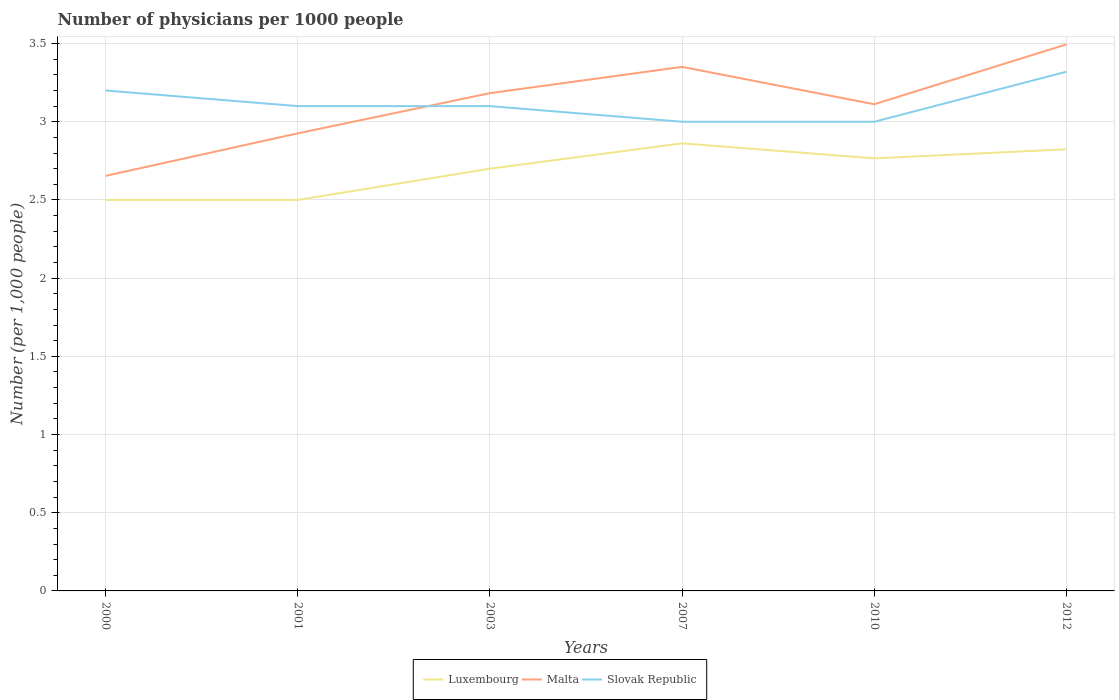How many different coloured lines are there?
Keep it short and to the point. 3. Is the number of lines equal to the number of legend labels?
Make the answer very short. Yes. In which year was the number of physicians in Luxembourg maximum?
Make the answer very short. 2000. What is the total number of physicians in Slovak Republic in the graph?
Keep it short and to the point. 0.1. What is the difference between the highest and the second highest number of physicians in Luxembourg?
Give a very brief answer. 0.36. What is the difference between the highest and the lowest number of physicians in Slovak Republic?
Your response must be concise. 2. Is the number of physicians in Slovak Republic strictly greater than the number of physicians in Luxembourg over the years?
Your answer should be compact. No. How many years are there in the graph?
Your response must be concise. 6. Does the graph contain grids?
Provide a succinct answer. Yes. Where does the legend appear in the graph?
Keep it short and to the point. Bottom center. How are the legend labels stacked?
Your answer should be compact. Horizontal. What is the title of the graph?
Keep it short and to the point. Number of physicians per 1000 people. What is the label or title of the X-axis?
Give a very brief answer. Years. What is the label or title of the Y-axis?
Make the answer very short. Number (per 1,0 people). What is the Number (per 1,000 people) of Malta in 2000?
Offer a terse response. 2.65. What is the Number (per 1,000 people) in Malta in 2001?
Give a very brief answer. 2.93. What is the Number (per 1,000 people) of Slovak Republic in 2001?
Your response must be concise. 3.1. What is the Number (per 1,000 people) of Malta in 2003?
Make the answer very short. 3.18. What is the Number (per 1,000 people) of Slovak Republic in 2003?
Provide a short and direct response. 3.1. What is the Number (per 1,000 people) in Luxembourg in 2007?
Provide a short and direct response. 2.86. What is the Number (per 1,000 people) in Malta in 2007?
Give a very brief answer. 3.35. What is the Number (per 1,000 people) in Slovak Republic in 2007?
Your response must be concise. 3. What is the Number (per 1,000 people) in Luxembourg in 2010?
Your response must be concise. 2.77. What is the Number (per 1,000 people) in Malta in 2010?
Your answer should be very brief. 3.11. What is the Number (per 1,000 people) in Slovak Republic in 2010?
Your answer should be compact. 3. What is the Number (per 1,000 people) of Luxembourg in 2012?
Ensure brevity in your answer.  2.82. What is the Number (per 1,000 people) of Malta in 2012?
Provide a succinct answer. 3.5. What is the Number (per 1,000 people) of Slovak Republic in 2012?
Provide a succinct answer. 3.32. Across all years, what is the maximum Number (per 1,000 people) in Luxembourg?
Provide a succinct answer. 2.86. Across all years, what is the maximum Number (per 1,000 people) of Malta?
Keep it short and to the point. 3.5. Across all years, what is the maximum Number (per 1,000 people) of Slovak Republic?
Keep it short and to the point. 3.32. Across all years, what is the minimum Number (per 1,000 people) in Luxembourg?
Your answer should be very brief. 2.5. Across all years, what is the minimum Number (per 1,000 people) in Malta?
Make the answer very short. 2.65. Across all years, what is the minimum Number (per 1,000 people) in Slovak Republic?
Provide a short and direct response. 3. What is the total Number (per 1,000 people) in Luxembourg in the graph?
Provide a short and direct response. 16.15. What is the total Number (per 1,000 people) of Malta in the graph?
Your answer should be very brief. 18.72. What is the total Number (per 1,000 people) of Slovak Republic in the graph?
Provide a succinct answer. 18.72. What is the difference between the Number (per 1,000 people) in Malta in 2000 and that in 2001?
Offer a terse response. -0.27. What is the difference between the Number (per 1,000 people) of Slovak Republic in 2000 and that in 2001?
Offer a terse response. 0.1. What is the difference between the Number (per 1,000 people) of Malta in 2000 and that in 2003?
Keep it short and to the point. -0.53. What is the difference between the Number (per 1,000 people) in Slovak Republic in 2000 and that in 2003?
Your answer should be very brief. 0.1. What is the difference between the Number (per 1,000 people) of Luxembourg in 2000 and that in 2007?
Your response must be concise. -0.36. What is the difference between the Number (per 1,000 people) in Malta in 2000 and that in 2007?
Give a very brief answer. -0.7. What is the difference between the Number (per 1,000 people) of Slovak Republic in 2000 and that in 2007?
Your answer should be compact. 0.2. What is the difference between the Number (per 1,000 people) of Luxembourg in 2000 and that in 2010?
Your response must be concise. -0.27. What is the difference between the Number (per 1,000 people) of Malta in 2000 and that in 2010?
Your response must be concise. -0.46. What is the difference between the Number (per 1,000 people) of Luxembourg in 2000 and that in 2012?
Provide a succinct answer. -0.32. What is the difference between the Number (per 1,000 people) of Malta in 2000 and that in 2012?
Ensure brevity in your answer.  -0.84. What is the difference between the Number (per 1,000 people) of Slovak Republic in 2000 and that in 2012?
Your response must be concise. -0.12. What is the difference between the Number (per 1,000 people) in Malta in 2001 and that in 2003?
Make the answer very short. -0.26. What is the difference between the Number (per 1,000 people) of Slovak Republic in 2001 and that in 2003?
Give a very brief answer. 0. What is the difference between the Number (per 1,000 people) in Luxembourg in 2001 and that in 2007?
Make the answer very short. -0.36. What is the difference between the Number (per 1,000 people) of Malta in 2001 and that in 2007?
Provide a short and direct response. -0.42. What is the difference between the Number (per 1,000 people) in Luxembourg in 2001 and that in 2010?
Your answer should be very brief. -0.27. What is the difference between the Number (per 1,000 people) of Malta in 2001 and that in 2010?
Keep it short and to the point. -0.19. What is the difference between the Number (per 1,000 people) in Luxembourg in 2001 and that in 2012?
Provide a succinct answer. -0.32. What is the difference between the Number (per 1,000 people) in Malta in 2001 and that in 2012?
Provide a succinct answer. -0.57. What is the difference between the Number (per 1,000 people) of Slovak Republic in 2001 and that in 2012?
Give a very brief answer. -0.22. What is the difference between the Number (per 1,000 people) in Luxembourg in 2003 and that in 2007?
Provide a short and direct response. -0.16. What is the difference between the Number (per 1,000 people) of Malta in 2003 and that in 2007?
Your response must be concise. -0.17. What is the difference between the Number (per 1,000 people) of Luxembourg in 2003 and that in 2010?
Ensure brevity in your answer.  -0.07. What is the difference between the Number (per 1,000 people) of Malta in 2003 and that in 2010?
Give a very brief answer. 0.07. What is the difference between the Number (per 1,000 people) in Luxembourg in 2003 and that in 2012?
Offer a very short reply. -0.12. What is the difference between the Number (per 1,000 people) in Malta in 2003 and that in 2012?
Offer a terse response. -0.31. What is the difference between the Number (per 1,000 people) of Slovak Republic in 2003 and that in 2012?
Your answer should be very brief. -0.22. What is the difference between the Number (per 1,000 people) in Luxembourg in 2007 and that in 2010?
Keep it short and to the point. 0.1. What is the difference between the Number (per 1,000 people) in Malta in 2007 and that in 2010?
Ensure brevity in your answer.  0.24. What is the difference between the Number (per 1,000 people) in Luxembourg in 2007 and that in 2012?
Make the answer very short. 0.04. What is the difference between the Number (per 1,000 people) in Malta in 2007 and that in 2012?
Offer a terse response. -0.14. What is the difference between the Number (per 1,000 people) of Slovak Republic in 2007 and that in 2012?
Your response must be concise. -0.32. What is the difference between the Number (per 1,000 people) of Luxembourg in 2010 and that in 2012?
Ensure brevity in your answer.  -0.06. What is the difference between the Number (per 1,000 people) in Malta in 2010 and that in 2012?
Your response must be concise. -0.38. What is the difference between the Number (per 1,000 people) of Slovak Republic in 2010 and that in 2012?
Provide a succinct answer. -0.32. What is the difference between the Number (per 1,000 people) of Luxembourg in 2000 and the Number (per 1,000 people) of Malta in 2001?
Your response must be concise. -0.43. What is the difference between the Number (per 1,000 people) of Malta in 2000 and the Number (per 1,000 people) of Slovak Republic in 2001?
Offer a very short reply. -0.45. What is the difference between the Number (per 1,000 people) of Luxembourg in 2000 and the Number (per 1,000 people) of Malta in 2003?
Provide a short and direct response. -0.68. What is the difference between the Number (per 1,000 people) in Luxembourg in 2000 and the Number (per 1,000 people) in Slovak Republic in 2003?
Offer a very short reply. -0.6. What is the difference between the Number (per 1,000 people) in Malta in 2000 and the Number (per 1,000 people) in Slovak Republic in 2003?
Ensure brevity in your answer.  -0.45. What is the difference between the Number (per 1,000 people) of Luxembourg in 2000 and the Number (per 1,000 people) of Malta in 2007?
Provide a succinct answer. -0.85. What is the difference between the Number (per 1,000 people) of Malta in 2000 and the Number (per 1,000 people) of Slovak Republic in 2007?
Offer a very short reply. -0.35. What is the difference between the Number (per 1,000 people) in Luxembourg in 2000 and the Number (per 1,000 people) in Malta in 2010?
Your answer should be compact. -0.61. What is the difference between the Number (per 1,000 people) of Malta in 2000 and the Number (per 1,000 people) of Slovak Republic in 2010?
Your answer should be very brief. -0.35. What is the difference between the Number (per 1,000 people) of Luxembourg in 2000 and the Number (per 1,000 people) of Malta in 2012?
Keep it short and to the point. -0.99. What is the difference between the Number (per 1,000 people) in Luxembourg in 2000 and the Number (per 1,000 people) in Slovak Republic in 2012?
Keep it short and to the point. -0.82. What is the difference between the Number (per 1,000 people) in Malta in 2000 and the Number (per 1,000 people) in Slovak Republic in 2012?
Provide a short and direct response. -0.67. What is the difference between the Number (per 1,000 people) in Luxembourg in 2001 and the Number (per 1,000 people) in Malta in 2003?
Offer a terse response. -0.68. What is the difference between the Number (per 1,000 people) in Malta in 2001 and the Number (per 1,000 people) in Slovak Republic in 2003?
Offer a very short reply. -0.17. What is the difference between the Number (per 1,000 people) of Luxembourg in 2001 and the Number (per 1,000 people) of Malta in 2007?
Your answer should be very brief. -0.85. What is the difference between the Number (per 1,000 people) in Luxembourg in 2001 and the Number (per 1,000 people) in Slovak Republic in 2007?
Make the answer very short. -0.5. What is the difference between the Number (per 1,000 people) of Malta in 2001 and the Number (per 1,000 people) of Slovak Republic in 2007?
Your response must be concise. -0.07. What is the difference between the Number (per 1,000 people) in Luxembourg in 2001 and the Number (per 1,000 people) in Malta in 2010?
Ensure brevity in your answer.  -0.61. What is the difference between the Number (per 1,000 people) of Luxembourg in 2001 and the Number (per 1,000 people) of Slovak Republic in 2010?
Ensure brevity in your answer.  -0.5. What is the difference between the Number (per 1,000 people) in Malta in 2001 and the Number (per 1,000 people) in Slovak Republic in 2010?
Your answer should be compact. -0.07. What is the difference between the Number (per 1,000 people) of Luxembourg in 2001 and the Number (per 1,000 people) of Malta in 2012?
Provide a succinct answer. -0.99. What is the difference between the Number (per 1,000 people) in Luxembourg in 2001 and the Number (per 1,000 people) in Slovak Republic in 2012?
Offer a very short reply. -0.82. What is the difference between the Number (per 1,000 people) in Malta in 2001 and the Number (per 1,000 people) in Slovak Republic in 2012?
Provide a short and direct response. -0.39. What is the difference between the Number (per 1,000 people) of Luxembourg in 2003 and the Number (per 1,000 people) of Malta in 2007?
Provide a short and direct response. -0.65. What is the difference between the Number (per 1,000 people) in Luxembourg in 2003 and the Number (per 1,000 people) in Slovak Republic in 2007?
Make the answer very short. -0.3. What is the difference between the Number (per 1,000 people) of Malta in 2003 and the Number (per 1,000 people) of Slovak Republic in 2007?
Offer a very short reply. 0.18. What is the difference between the Number (per 1,000 people) in Luxembourg in 2003 and the Number (per 1,000 people) in Malta in 2010?
Your answer should be compact. -0.41. What is the difference between the Number (per 1,000 people) of Luxembourg in 2003 and the Number (per 1,000 people) of Slovak Republic in 2010?
Give a very brief answer. -0.3. What is the difference between the Number (per 1,000 people) in Malta in 2003 and the Number (per 1,000 people) in Slovak Republic in 2010?
Offer a very short reply. 0.18. What is the difference between the Number (per 1,000 people) in Luxembourg in 2003 and the Number (per 1,000 people) in Malta in 2012?
Your answer should be compact. -0.8. What is the difference between the Number (per 1,000 people) in Luxembourg in 2003 and the Number (per 1,000 people) in Slovak Republic in 2012?
Offer a terse response. -0.62. What is the difference between the Number (per 1,000 people) of Malta in 2003 and the Number (per 1,000 people) of Slovak Republic in 2012?
Offer a terse response. -0.14. What is the difference between the Number (per 1,000 people) of Luxembourg in 2007 and the Number (per 1,000 people) of Slovak Republic in 2010?
Offer a terse response. -0.14. What is the difference between the Number (per 1,000 people) of Malta in 2007 and the Number (per 1,000 people) of Slovak Republic in 2010?
Provide a short and direct response. 0.35. What is the difference between the Number (per 1,000 people) in Luxembourg in 2007 and the Number (per 1,000 people) in Malta in 2012?
Give a very brief answer. -0.63. What is the difference between the Number (per 1,000 people) in Luxembourg in 2007 and the Number (per 1,000 people) in Slovak Republic in 2012?
Your answer should be very brief. -0.46. What is the difference between the Number (per 1,000 people) of Malta in 2007 and the Number (per 1,000 people) of Slovak Republic in 2012?
Provide a short and direct response. 0.03. What is the difference between the Number (per 1,000 people) in Luxembourg in 2010 and the Number (per 1,000 people) in Malta in 2012?
Your answer should be very brief. -0.73. What is the difference between the Number (per 1,000 people) of Luxembourg in 2010 and the Number (per 1,000 people) of Slovak Republic in 2012?
Your answer should be compact. -0.55. What is the difference between the Number (per 1,000 people) in Malta in 2010 and the Number (per 1,000 people) in Slovak Republic in 2012?
Your answer should be very brief. -0.21. What is the average Number (per 1,000 people) in Luxembourg per year?
Give a very brief answer. 2.69. What is the average Number (per 1,000 people) in Malta per year?
Give a very brief answer. 3.12. What is the average Number (per 1,000 people) of Slovak Republic per year?
Your response must be concise. 3.12. In the year 2000, what is the difference between the Number (per 1,000 people) in Luxembourg and Number (per 1,000 people) in Malta?
Offer a very short reply. -0.15. In the year 2000, what is the difference between the Number (per 1,000 people) in Luxembourg and Number (per 1,000 people) in Slovak Republic?
Your response must be concise. -0.7. In the year 2000, what is the difference between the Number (per 1,000 people) in Malta and Number (per 1,000 people) in Slovak Republic?
Ensure brevity in your answer.  -0.55. In the year 2001, what is the difference between the Number (per 1,000 people) in Luxembourg and Number (per 1,000 people) in Malta?
Your answer should be very brief. -0.43. In the year 2001, what is the difference between the Number (per 1,000 people) in Luxembourg and Number (per 1,000 people) in Slovak Republic?
Provide a short and direct response. -0.6. In the year 2001, what is the difference between the Number (per 1,000 people) in Malta and Number (per 1,000 people) in Slovak Republic?
Give a very brief answer. -0.17. In the year 2003, what is the difference between the Number (per 1,000 people) of Luxembourg and Number (per 1,000 people) of Malta?
Give a very brief answer. -0.48. In the year 2003, what is the difference between the Number (per 1,000 people) in Malta and Number (per 1,000 people) in Slovak Republic?
Keep it short and to the point. 0.08. In the year 2007, what is the difference between the Number (per 1,000 people) of Luxembourg and Number (per 1,000 people) of Malta?
Your answer should be very brief. -0.49. In the year 2007, what is the difference between the Number (per 1,000 people) of Luxembourg and Number (per 1,000 people) of Slovak Republic?
Your answer should be compact. -0.14. In the year 2007, what is the difference between the Number (per 1,000 people) in Malta and Number (per 1,000 people) in Slovak Republic?
Keep it short and to the point. 0.35. In the year 2010, what is the difference between the Number (per 1,000 people) in Luxembourg and Number (per 1,000 people) in Malta?
Provide a short and direct response. -0.35. In the year 2010, what is the difference between the Number (per 1,000 people) in Luxembourg and Number (per 1,000 people) in Slovak Republic?
Your answer should be compact. -0.23. In the year 2010, what is the difference between the Number (per 1,000 people) in Malta and Number (per 1,000 people) in Slovak Republic?
Provide a succinct answer. 0.11. In the year 2012, what is the difference between the Number (per 1,000 people) of Luxembourg and Number (per 1,000 people) of Malta?
Keep it short and to the point. -0.67. In the year 2012, what is the difference between the Number (per 1,000 people) of Luxembourg and Number (per 1,000 people) of Slovak Republic?
Offer a very short reply. -0.5. In the year 2012, what is the difference between the Number (per 1,000 people) in Malta and Number (per 1,000 people) in Slovak Republic?
Offer a terse response. 0.17. What is the ratio of the Number (per 1,000 people) in Luxembourg in 2000 to that in 2001?
Provide a succinct answer. 1. What is the ratio of the Number (per 1,000 people) in Malta in 2000 to that in 2001?
Offer a very short reply. 0.91. What is the ratio of the Number (per 1,000 people) in Slovak Republic in 2000 to that in 2001?
Your answer should be very brief. 1.03. What is the ratio of the Number (per 1,000 people) in Luxembourg in 2000 to that in 2003?
Ensure brevity in your answer.  0.93. What is the ratio of the Number (per 1,000 people) of Malta in 2000 to that in 2003?
Keep it short and to the point. 0.83. What is the ratio of the Number (per 1,000 people) of Slovak Republic in 2000 to that in 2003?
Keep it short and to the point. 1.03. What is the ratio of the Number (per 1,000 people) of Luxembourg in 2000 to that in 2007?
Make the answer very short. 0.87. What is the ratio of the Number (per 1,000 people) in Malta in 2000 to that in 2007?
Make the answer very short. 0.79. What is the ratio of the Number (per 1,000 people) of Slovak Republic in 2000 to that in 2007?
Keep it short and to the point. 1.07. What is the ratio of the Number (per 1,000 people) in Luxembourg in 2000 to that in 2010?
Your response must be concise. 0.9. What is the ratio of the Number (per 1,000 people) of Malta in 2000 to that in 2010?
Offer a very short reply. 0.85. What is the ratio of the Number (per 1,000 people) of Slovak Republic in 2000 to that in 2010?
Give a very brief answer. 1.07. What is the ratio of the Number (per 1,000 people) of Luxembourg in 2000 to that in 2012?
Offer a terse response. 0.89. What is the ratio of the Number (per 1,000 people) of Malta in 2000 to that in 2012?
Ensure brevity in your answer.  0.76. What is the ratio of the Number (per 1,000 people) of Slovak Republic in 2000 to that in 2012?
Your answer should be compact. 0.96. What is the ratio of the Number (per 1,000 people) of Luxembourg in 2001 to that in 2003?
Offer a terse response. 0.93. What is the ratio of the Number (per 1,000 people) in Malta in 2001 to that in 2003?
Provide a short and direct response. 0.92. What is the ratio of the Number (per 1,000 people) in Slovak Republic in 2001 to that in 2003?
Ensure brevity in your answer.  1. What is the ratio of the Number (per 1,000 people) of Luxembourg in 2001 to that in 2007?
Provide a short and direct response. 0.87. What is the ratio of the Number (per 1,000 people) of Malta in 2001 to that in 2007?
Give a very brief answer. 0.87. What is the ratio of the Number (per 1,000 people) in Luxembourg in 2001 to that in 2010?
Your response must be concise. 0.9. What is the ratio of the Number (per 1,000 people) in Malta in 2001 to that in 2010?
Offer a very short reply. 0.94. What is the ratio of the Number (per 1,000 people) in Luxembourg in 2001 to that in 2012?
Your answer should be compact. 0.89. What is the ratio of the Number (per 1,000 people) in Malta in 2001 to that in 2012?
Your answer should be very brief. 0.84. What is the ratio of the Number (per 1,000 people) in Slovak Republic in 2001 to that in 2012?
Make the answer very short. 0.93. What is the ratio of the Number (per 1,000 people) in Luxembourg in 2003 to that in 2007?
Your answer should be very brief. 0.94. What is the ratio of the Number (per 1,000 people) in Malta in 2003 to that in 2007?
Provide a succinct answer. 0.95. What is the ratio of the Number (per 1,000 people) of Slovak Republic in 2003 to that in 2007?
Ensure brevity in your answer.  1.03. What is the ratio of the Number (per 1,000 people) of Luxembourg in 2003 to that in 2010?
Make the answer very short. 0.98. What is the ratio of the Number (per 1,000 people) of Malta in 2003 to that in 2010?
Offer a very short reply. 1.02. What is the ratio of the Number (per 1,000 people) of Luxembourg in 2003 to that in 2012?
Your answer should be very brief. 0.96. What is the ratio of the Number (per 1,000 people) of Malta in 2003 to that in 2012?
Your answer should be very brief. 0.91. What is the ratio of the Number (per 1,000 people) in Slovak Republic in 2003 to that in 2012?
Your answer should be very brief. 0.93. What is the ratio of the Number (per 1,000 people) of Luxembourg in 2007 to that in 2010?
Provide a succinct answer. 1.03. What is the ratio of the Number (per 1,000 people) of Malta in 2007 to that in 2010?
Provide a succinct answer. 1.08. What is the ratio of the Number (per 1,000 people) of Luxembourg in 2007 to that in 2012?
Provide a short and direct response. 1.01. What is the ratio of the Number (per 1,000 people) of Malta in 2007 to that in 2012?
Make the answer very short. 0.96. What is the ratio of the Number (per 1,000 people) in Slovak Republic in 2007 to that in 2012?
Offer a terse response. 0.9. What is the ratio of the Number (per 1,000 people) in Luxembourg in 2010 to that in 2012?
Offer a terse response. 0.98. What is the ratio of the Number (per 1,000 people) of Malta in 2010 to that in 2012?
Your answer should be very brief. 0.89. What is the ratio of the Number (per 1,000 people) in Slovak Republic in 2010 to that in 2012?
Your response must be concise. 0.9. What is the difference between the highest and the second highest Number (per 1,000 people) of Luxembourg?
Give a very brief answer. 0.04. What is the difference between the highest and the second highest Number (per 1,000 people) of Malta?
Keep it short and to the point. 0.14. What is the difference between the highest and the second highest Number (per 1,000 people) of Slovak Republic?
Your response must be concise. 0.12. What is the difference between the highest and the lowest Number (per 1,000 people) of Luxembourg?
Provide a short and direct response. 0.36. What is the difference between the highest and the lowest Number (per 1,000 people) of Malta?
Keep it short and to the point. 0.84. What is the difference between the highest and the lowest Number (per 1,000 people) of Slovak Republic?
Keep it short and to the point. 0.32. 